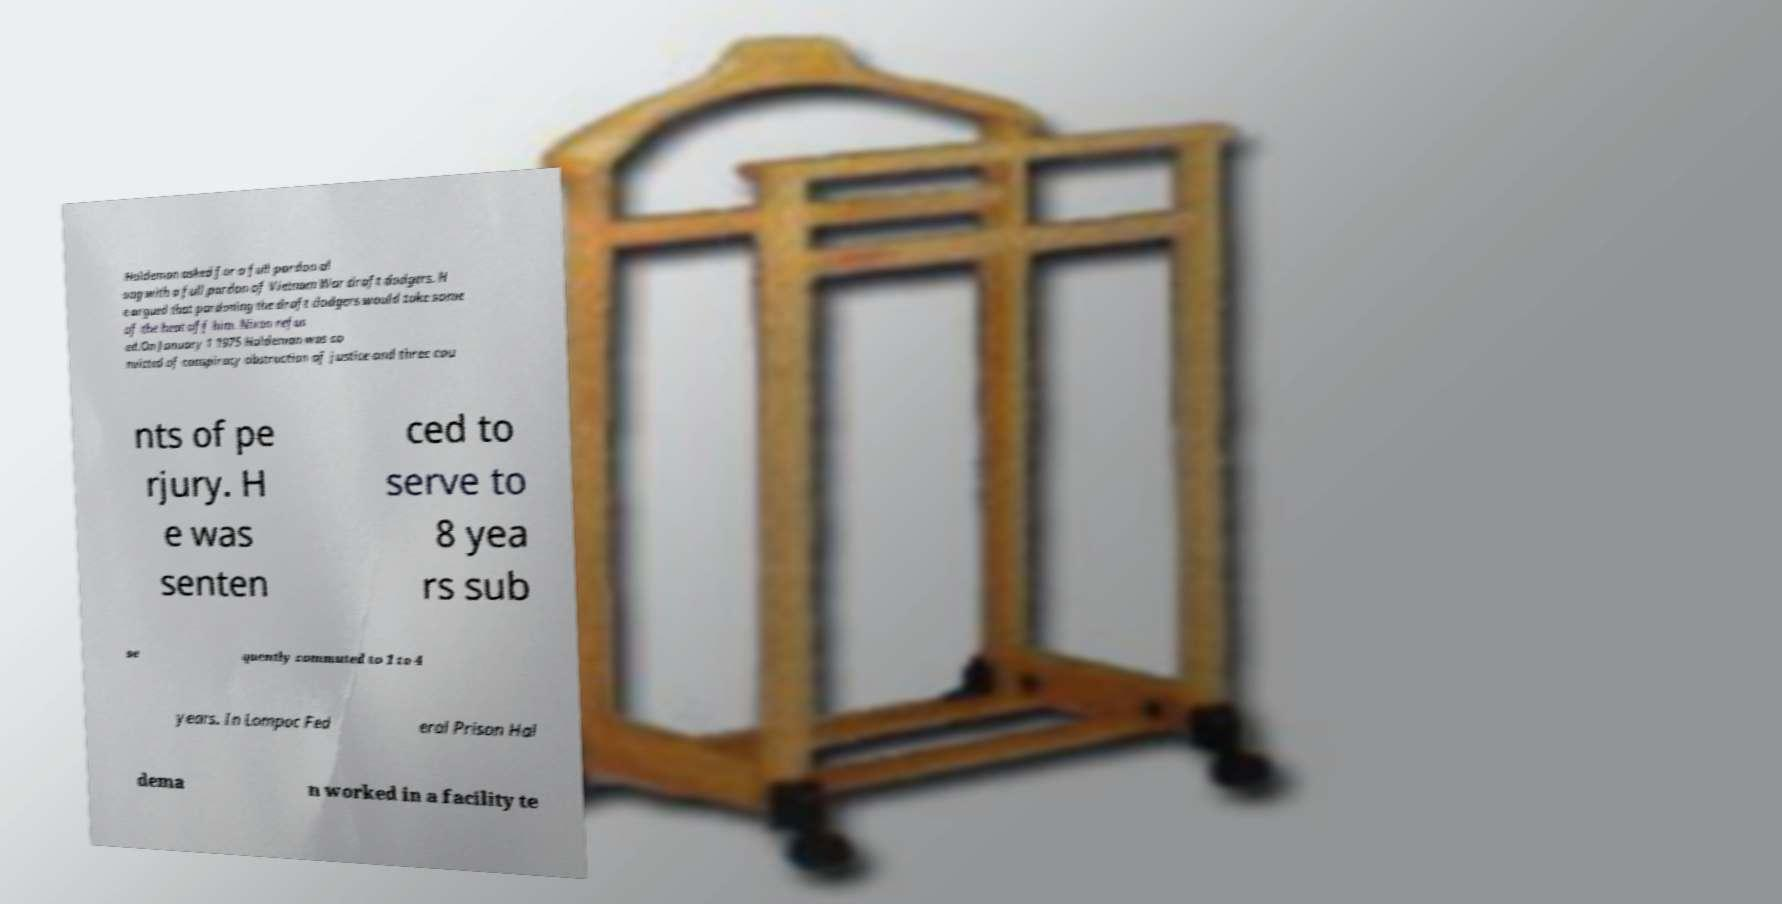Could you assist in decoding the text presented in this image and type it out clearly? Haldeman asked for a full pardon al ong with a full pardon of Vietnam War draft dodgers. H e argued that pardoning the draft dodgers would take some of the heat off him. Nixon refus ed.On January 1 1975 Haldeman was co nvicted of conspiracy obstruction of justice and three cou nts of pe rjury. H e was senten ced to serve to 8 yea rs sub se quently commuted to 1 to 4 years. In Lompoc Fed eral Prison Hal dema n worked in a facility te 